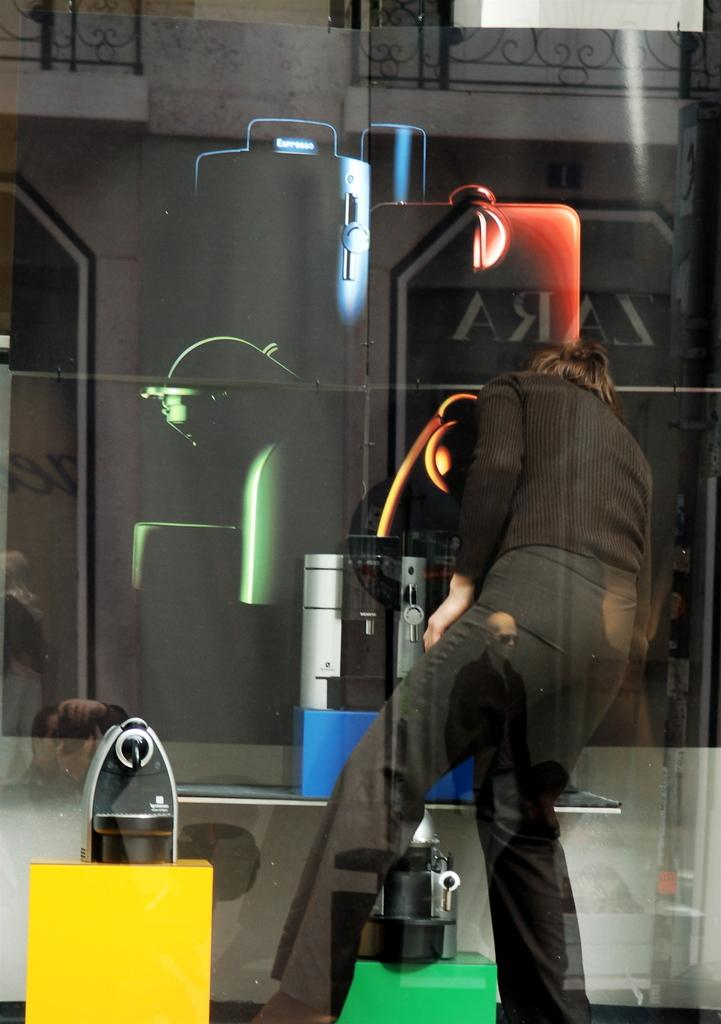What is the person in the image wearing? There is a person wearing a black dress in the image. How would you describe the person's appearance? The person is stunning. Can you identify any other objects or people in the image? There is a reflection of a person holding a camera in the image. What can be seen in the background of the image? There is a building visible in the image. How many girls are wearing coats in the image? There are no girls or coats present in the image. What is the condition of the person's knee in the image? There is no information about the person's knee in the image. 